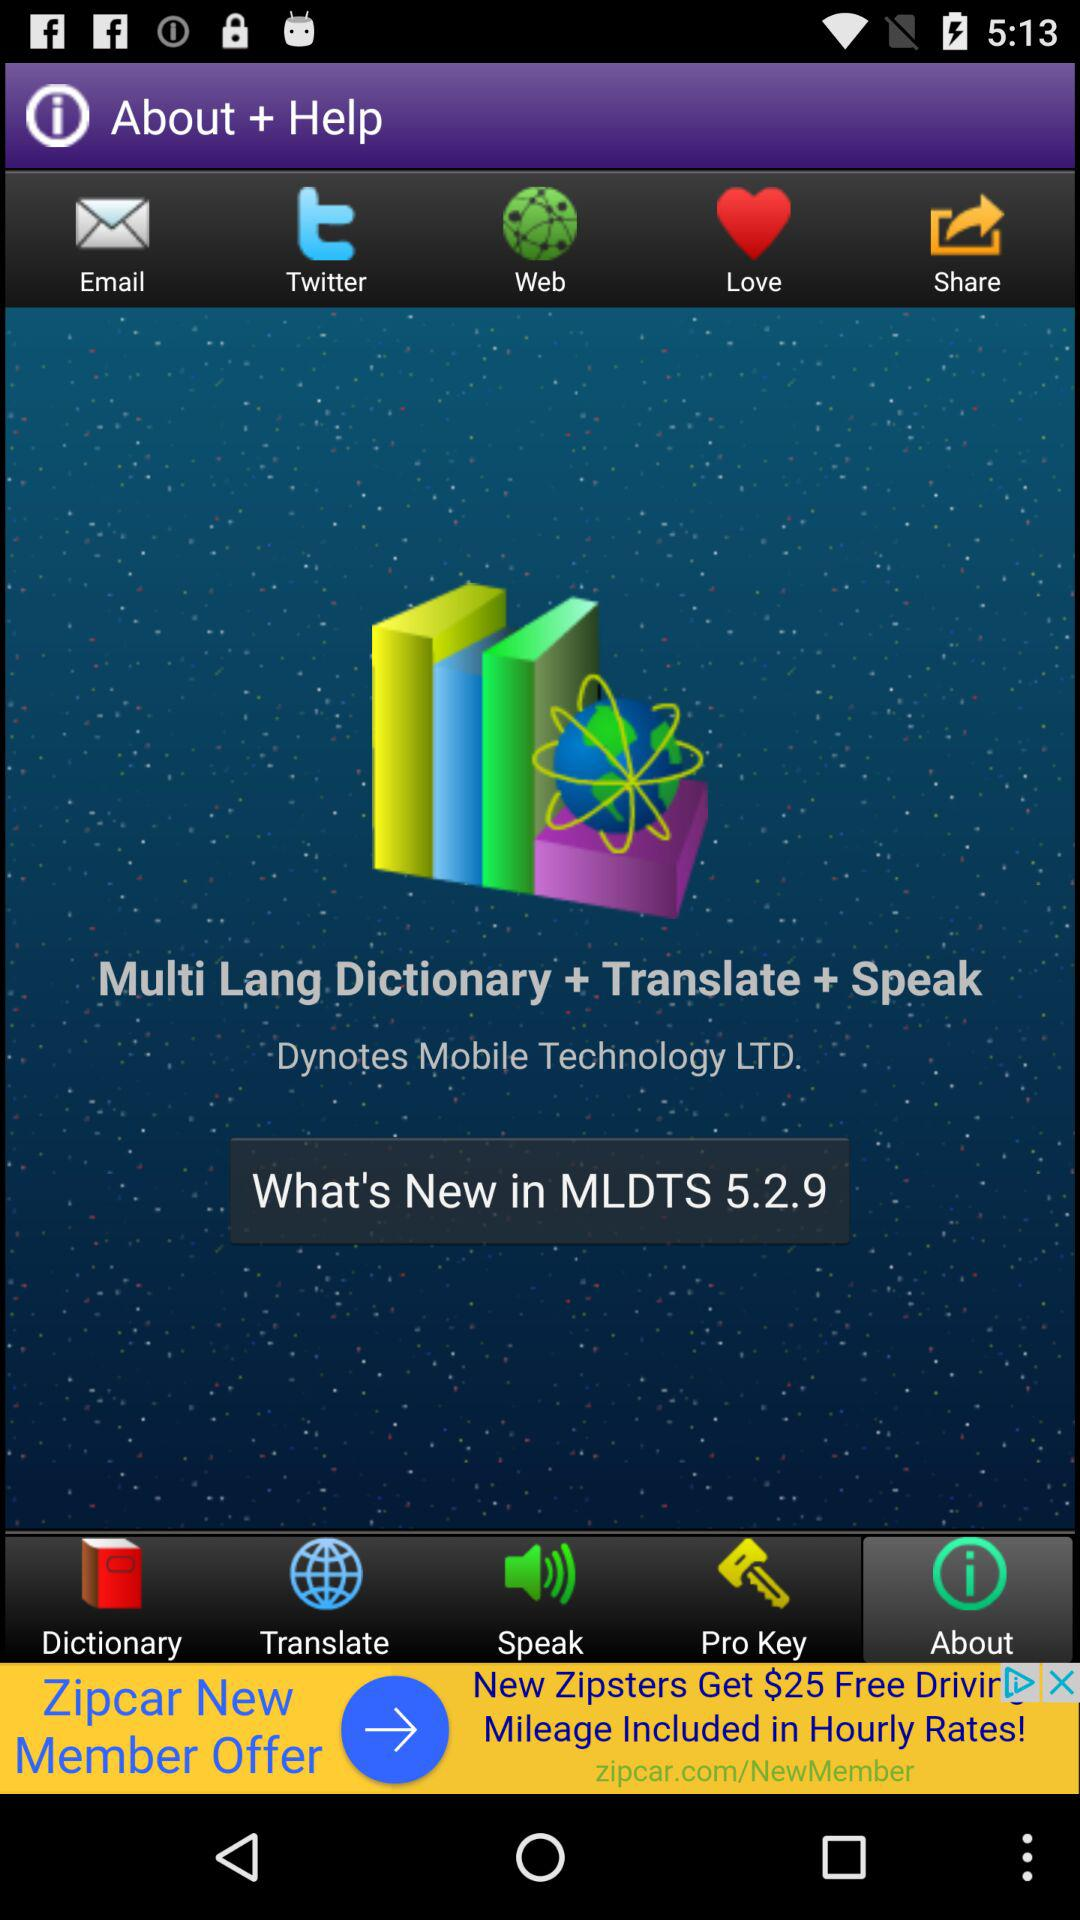Which option is selected? The selected option is "About". 